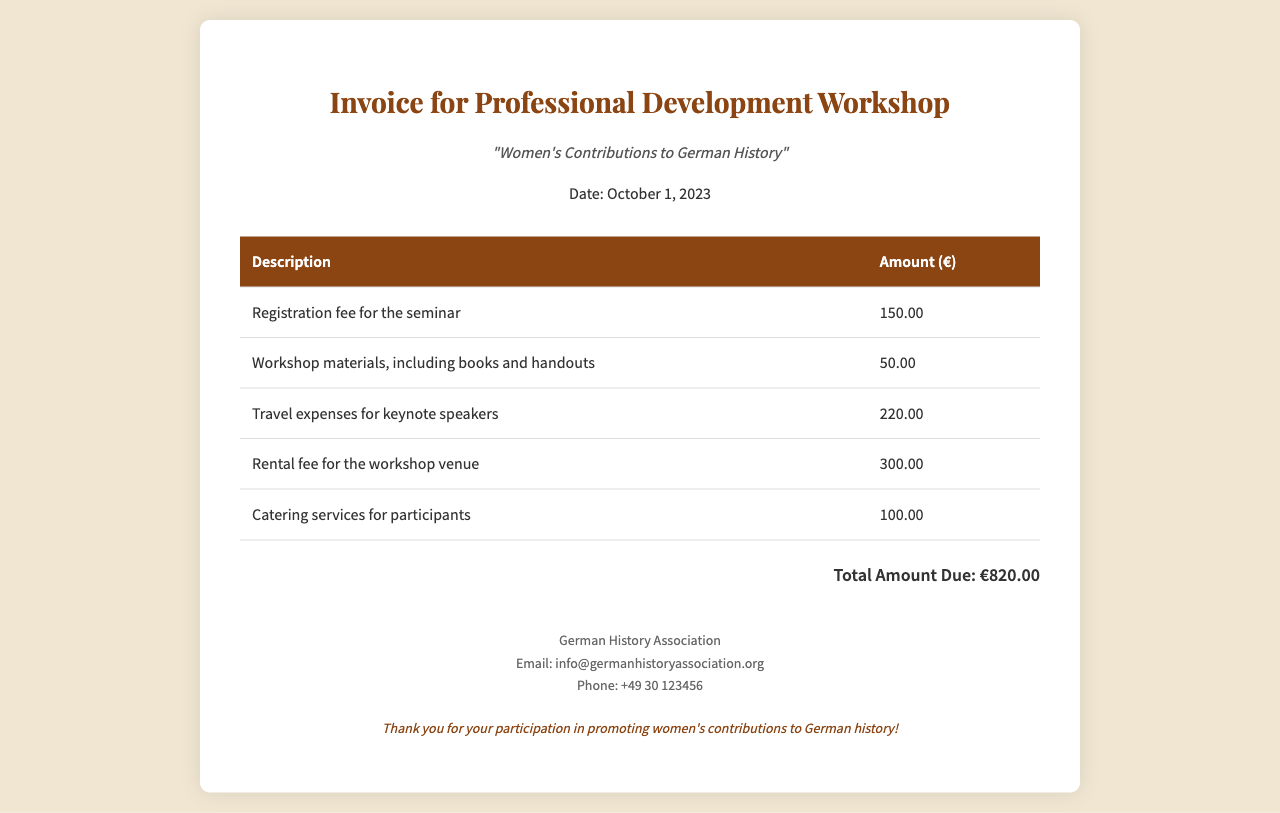what is the title of the workshop? The title of the workshop is explicitly stated in the document as "Women's Contributions to German History."
Answer: Women's Contributions to German History what is the date of the seminar? The date is clearly mentioned in the document as October 1, 2023.
Answer: October 1, 2023 how much is the registration fee? The registration fee is listed in the breakdown section of the document as 150.00 euros.
Answer: 150.00 what is the total amount due? The total amount due is calculated as the sum of all the costs listed, which is stated as €820.00.
Answer: €820.00 how much does the catering service cost? The cost for catering services is specified in the cost breakdown as 100.00 euros.
Answer: 100.00 what is included in the workshop materials? The workshop materials description indicates that it includes books and handouts.
Answer: books and handouts what is the cost for travel expenses? The travel expenses for keynote speakers are detailed in the document as 220.00 euros.
Answer: 220.00 who issued the invoice? The invoice is issued by the organization identified as the German History Association.
Answer: German History Association why are the costs associated with travel expenses important? Travel expenses are important as they indicate the logistics and resource allocation for bringing in expertise to the seminar.
Answer: expertise 